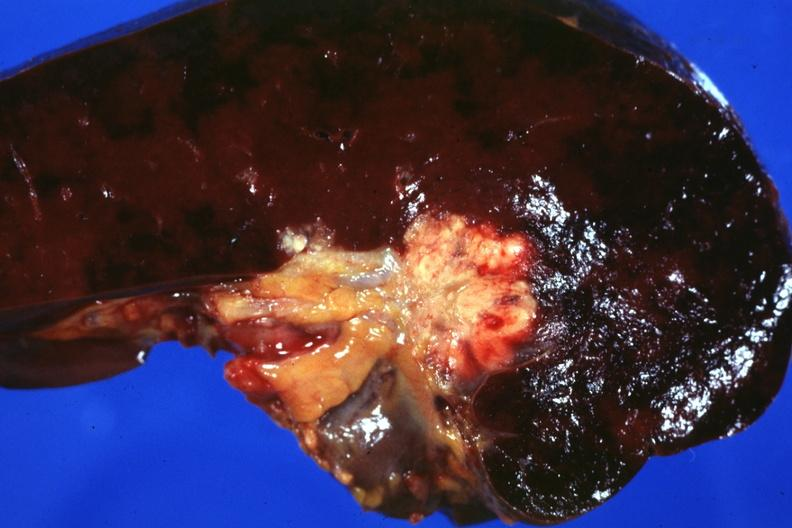what does this photo make?
Answer the question using a single word or phrase. One wonder whether node metastases spread into the spleen in case 